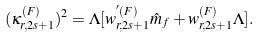<formula> <loc_0><loc_0><loc_500><loc_500>( \kappa _ { r , 2 s + 1 } ^ { ( F ) } ) ^ { 2 } = \Lambda [ w _ { r , 2 s + 1 } ^ { ^ { \prime } ( F ) } \hat { m } _ { f } + w _ { r , 2 s + 1 } ^ { ( F ) } \Lambda ] .</formula> 